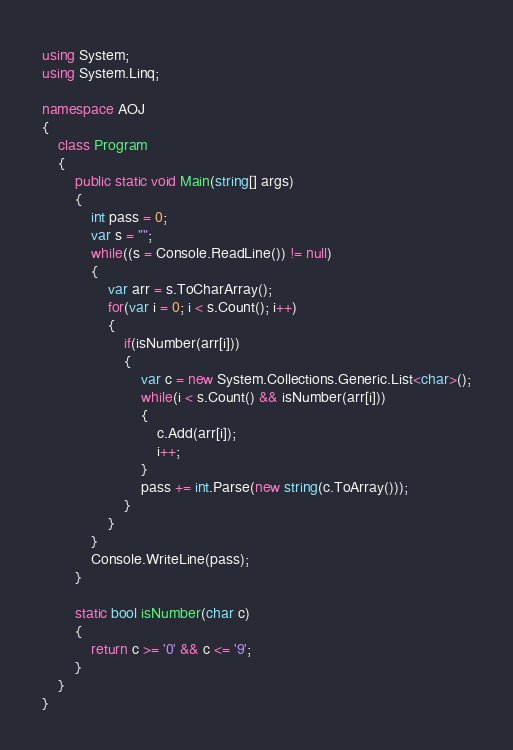<code> <loc_0><loc_0><loc_500><loc_500><_C#_>using System;
using System.Linq;

namespace AOJ
{
	class Program
	{
		public static void Main(string[] args)
		{
			int pass = 0;
			var s = "";
			while((s = Console.ReadLine()) != null)
			{
				var arr = s.ToCharArray();
				for(var i = 0; i < s.Count(); i++)
				{
					if(isNumber(arr[i]))
					{
						var c = new System.Collections.Generic.List<char>();
						while(i < s.Count() && isNumber(arr[i]))
						{
							c.Add(arr[i]);
							i++;
						}
						pass += int.Parse(new string(c.ToArray()));
					}
				}
			}
			Console.WriteLine(pass);
		}
		
		static bool isNumber(char c)
		{
			return c >= '0' && c <= '9';
		}
	}
}</code> 